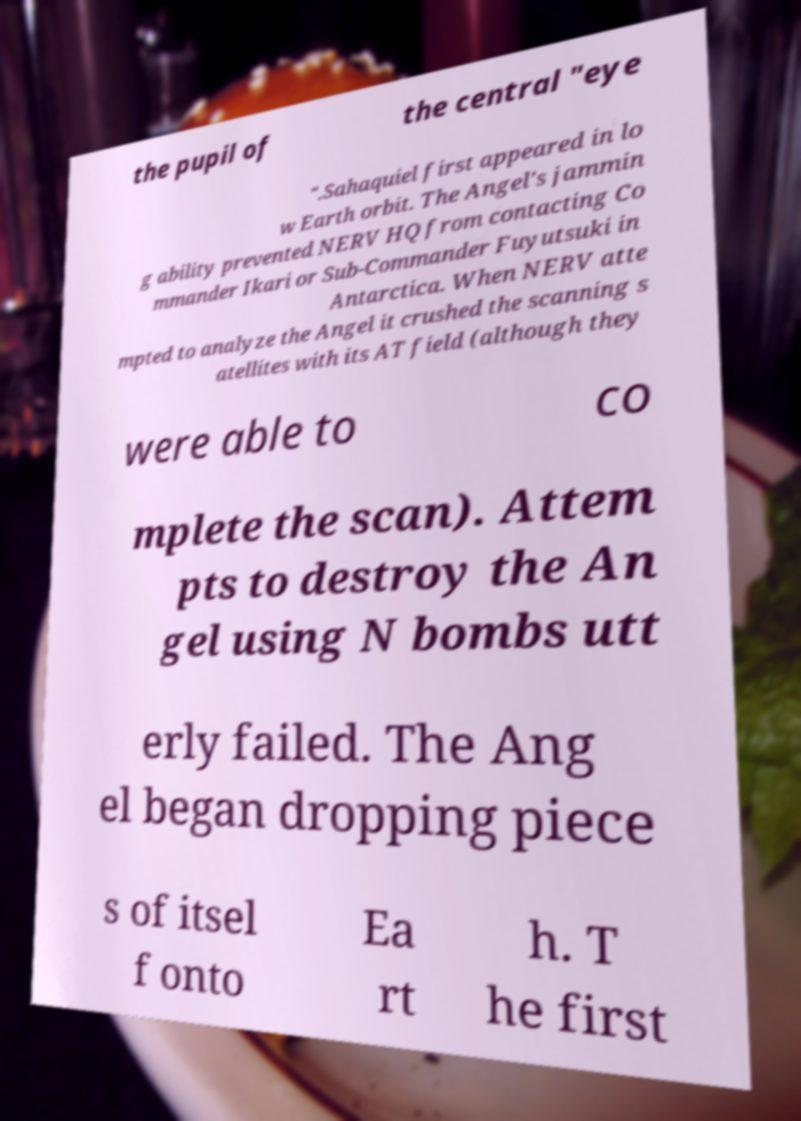Could you assist in decoding the text presented in this image and type it out clearly? the pupil of the central "eye ".Sahaquiel first appeared in lo w Earth orbit. The Angel's jammin g ability prevented NERV HQ from contacting Co mmander Ikari or Sub-Commander Fuyutsuki in Antarctica. When NERV atte mpted to analyze the Angel it crushed the scanning s atellites with its AT field (although they were able to co mplete the scan). Attem pts to destroy the An gel using N bombs utt erly failed. The Ang el began dropping piece s of itsel f onto Ea rt h. T he first 